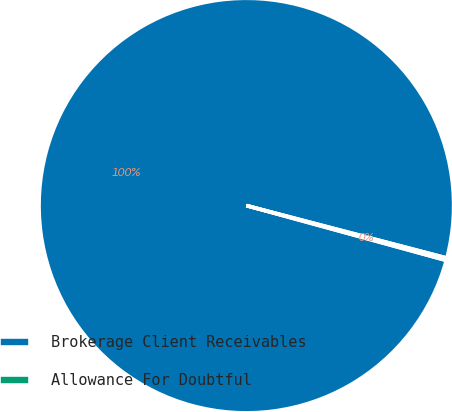Convert chart to OTSL. <chart><loc_0><loc_0><loc_500><loc_500><pie_chart><fcel>Brokerage Client Receivables<fcel>Allowance For Doubtful<nl><fcel>99.81%<fcel>0.19%<nl></chart> 